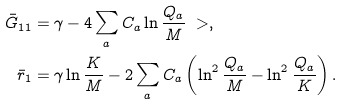Convert formula to latex. <formula><loc_0><loc_0><loc_500><loc_500>\bar { G } _ { 1 1 } & = \gamma - 4 \sum _ { a } C _ { a } \ln \frac { Q _ { a } } { M } \ > , \\ \bar { r } _ { 1 } & = \gamma \ln \frac { K } { M } - 2 \sum _ { a } C _ { a } \left ( \ln ^ { 2 } \frac { Q _ { a } } { M } - \ln ^ { 2 } \frac { Q _ { a } } { K } \right ) .</formula> 